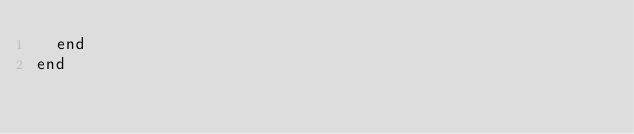<code> <loc_0><loc_0><loc_500><loc_500><_Ruby_>  end
end
</code> 